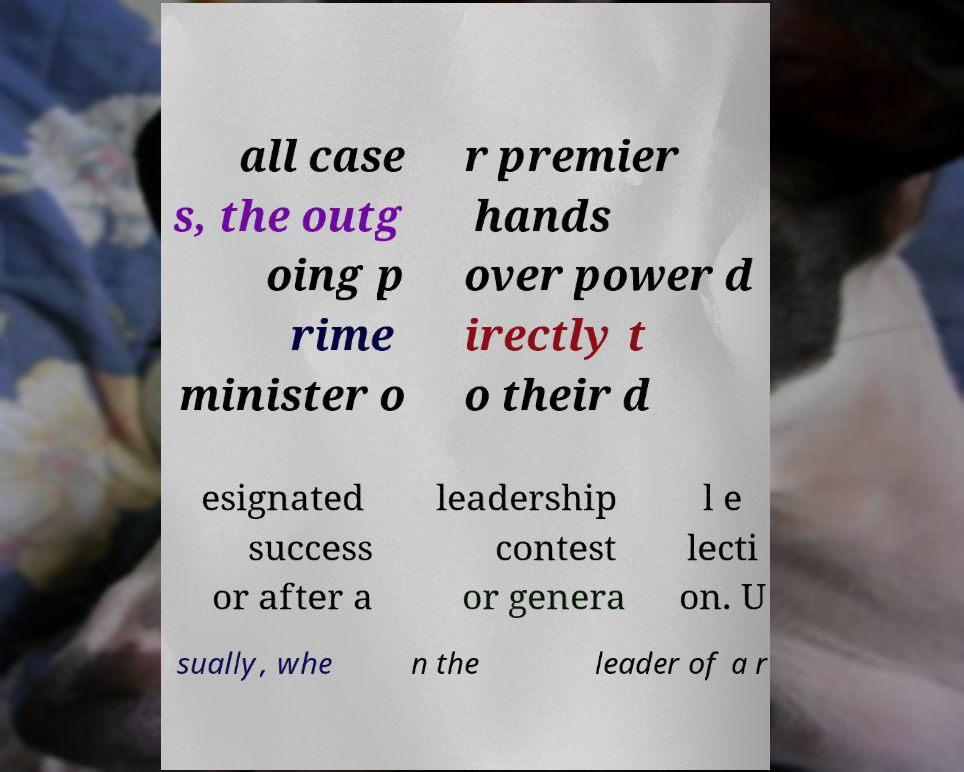Please identify and transcribe the text found in this image. all case s, the outg oing p rime minister o r premier hands over power d irectly t o their d esignated success or after a leadership contest or genera l e lecti on. U sually, whe n the leader of a r 